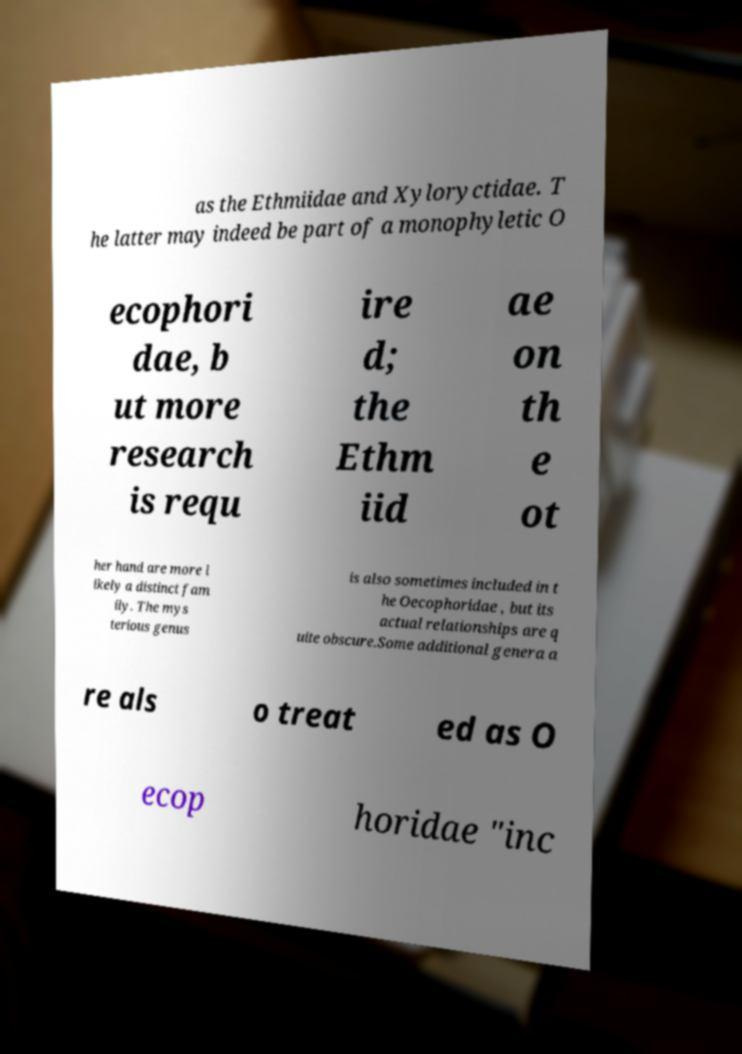There's text embedded in this image that I need extracted. Can you transcribe it verbatim? as the Ethmiidae and Xyloryctidae. T he latter may indeed be part of a monophyletic O ecophori dae, b ut more research is requ ire d; the Ethm iid ae on th e ot her hand are more l ikely a distinct fam ily. The mys terious genus is also sometimes included in t he Oecophoridae , but its actual relationships are q uite obscure.Some additional genera a re als o treat ed as O ecop horidae "inc 